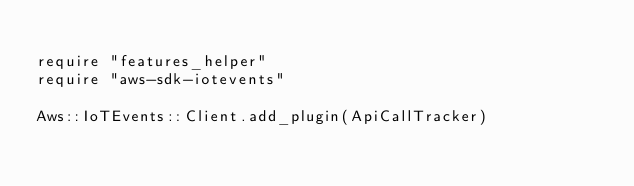Convert code to text. <code><loc_0><loc_0><loc_500><loc_500><_Crystal_>
require "features_helper"
require "aws-sdk-iotevents"

Aws::IoTEvents::Client.add_plugin(ApiCallTracker)
</code> 